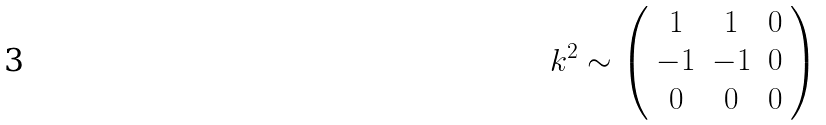<formula> <loc_0><loc_0><loc_500><loc_500>k ^ { 2 } \sim \left ( \begin{array} { c c c } 1 & 1 & 0 \\ - 1 & - 1 & 0 \\ 0 & 0 & 0 \end{array} \right )</formula> 